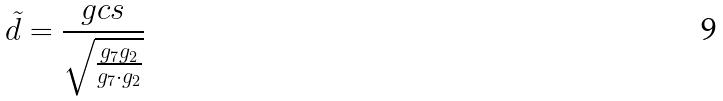<formula> <loc_0><loc_0><loc_500><loc_500>\tilde { d } = \frac { g c s } { \sqrt { \frac { g _ { 7 } g _ { 2 } } { g _ { 7 } \cdot g _ { 2 } } } }</formula> 